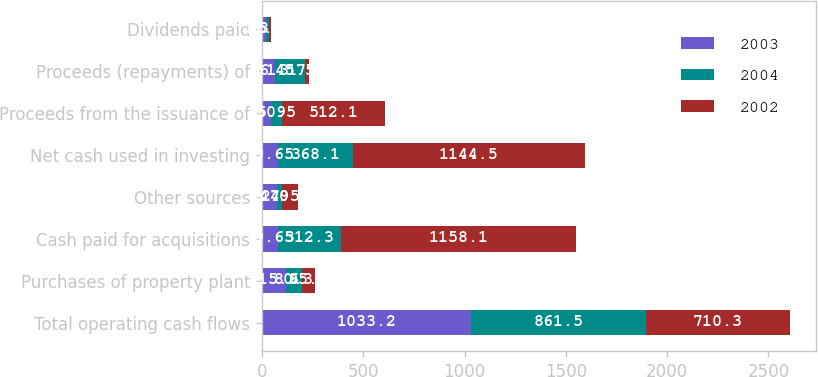Convert chart. <chart><loc_0><loc_0><loc_500><loc_500><stacked_bar_chart><ecel><fcel>Total operating cash flows<fcel>Purchases of property plant<fcel>Cash paid for acquisitions<fcel>Other sources<fcel>Net cash used in investing<fcel>Proceeds from the issuance of<fcel>Proceeds (repayments) of<fcel>Dividends paid<nl><fcel>2003<fcel>1033.2<fcel>115.9<fcel>79.65<fcel>74<fcel>79.65<fcel>45.9<fcel>66.3<fcel>17.7<nl><fcel>2004<fcel>861.5<fcel>80.3<fcel>312.3<fcel>24.5<fcel>368.1<fcel>50.5<fcel>145.5<fcel>15.3<nl><fcel>2002<fcel>710.3<fcel>65.4<fcel>1158.1<fcel>79<fcel>1144.5<fcel>512.1<fcel>17.7<fcel>13.5<nl></chart> 